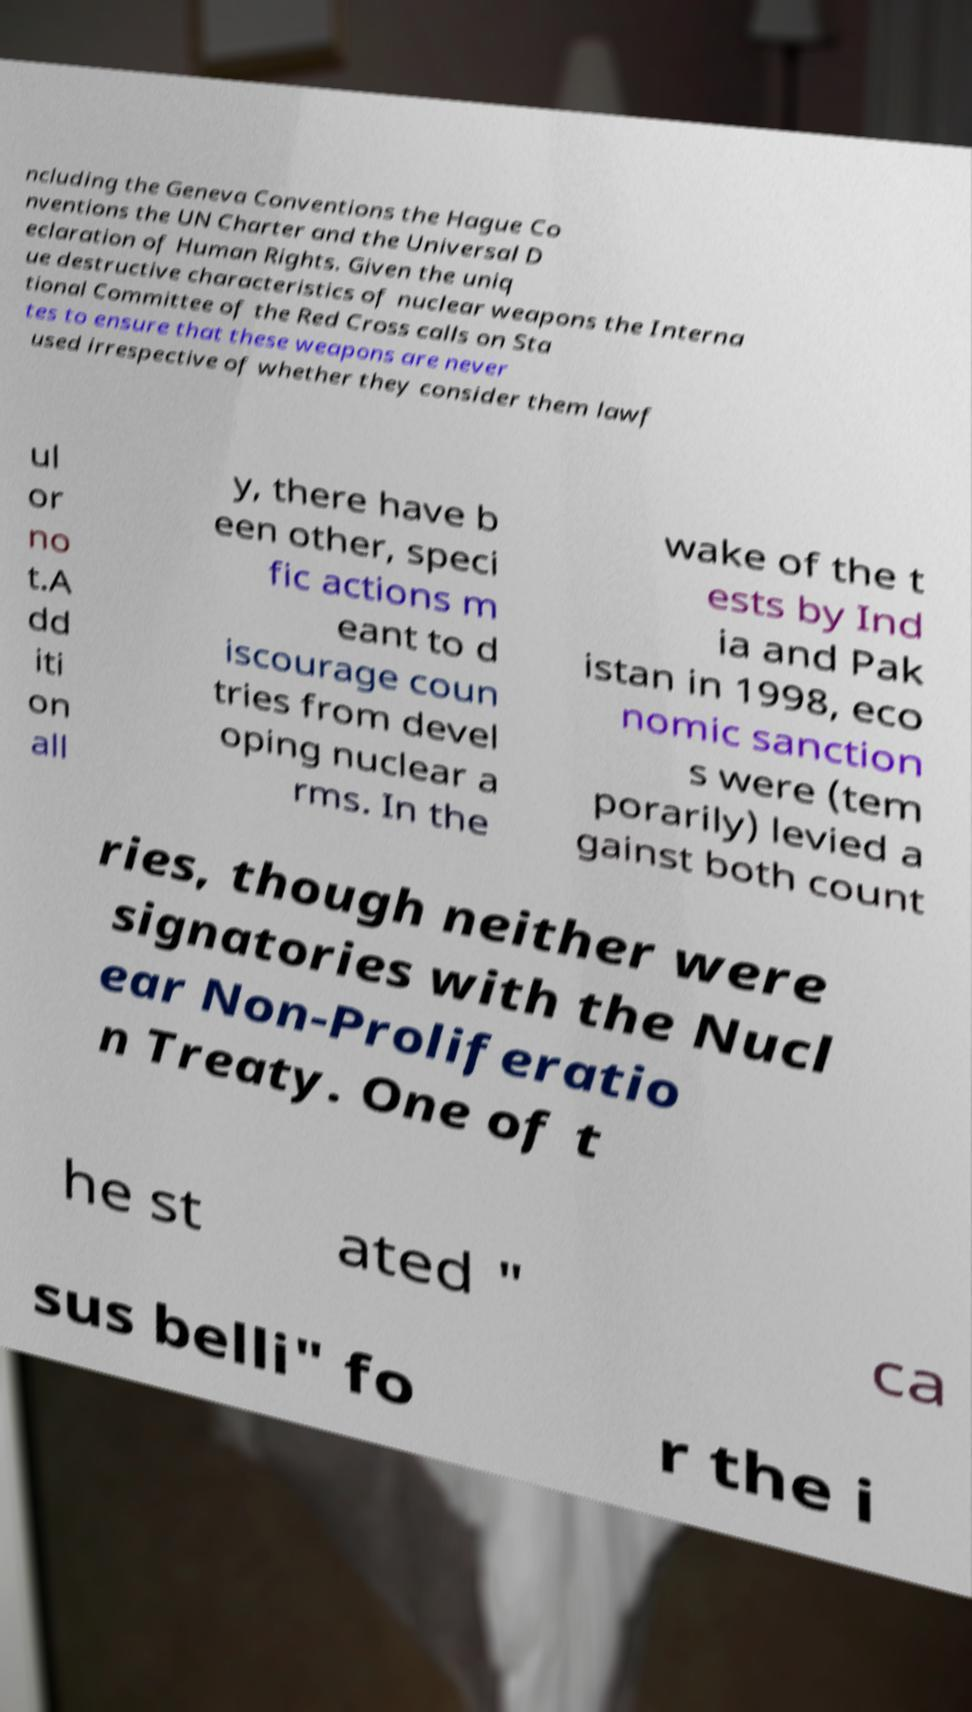For documentation purposes, I need the text within this image transcribed. Could you provide that? ncluding the Geneva Conventions the Hague Co nventions the UN Charter and the Universal D eclaration of Human Rights. Given the uniq ue destructive characteristics of nuclear weapons the Interna tional Committee of the Red Cross calls on Sta tes to ensure that these weapons are never used irrespective of whether they consider them lawf ul or no t.A dd iti on all y, there have b een other, speci fic actions m eant to d iscourage coun tries from devel oping nuclear a rms. In the wake of the t ests by Ind ia and Pak istan in 1998, eco nomic sanction s were (tem porarily) levied a gainst both count ries, though neither were signatories with the Nucl ear Non-Proliferatio n Treaty. One of t he st ated " ca sus belli" fo r the i 